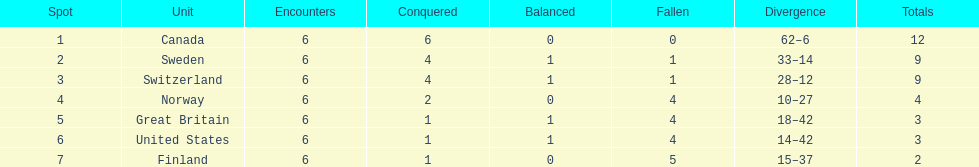Which country conceded the least goals? Finland. 